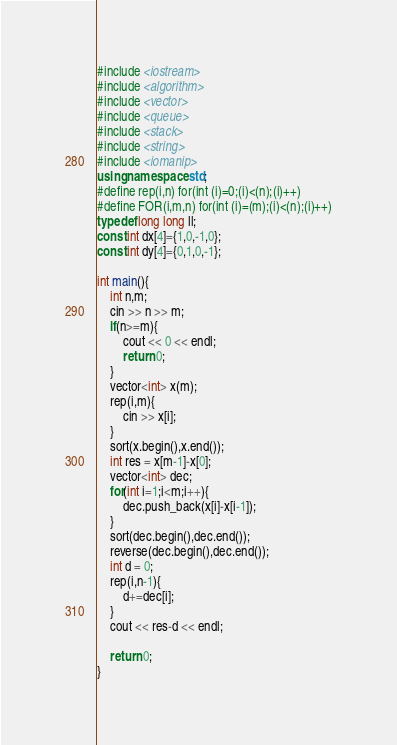Convert code to text. <code><loc_0><loc_0><loc_500><loc_500><_C++_>#include <iostream>
#include <algorithm>
#include <vector>
#include <queue>
#include <stack>
#include <string>
#include <iomanip>
using namespace std;
#define rep(i,n) for(int (i)=0;(i)<(n);(i)++)
#define FOR(i,m,n) for(int (i)=(m);(i)<(n);(i)++)
typedef long long ll;
const int dx[4]={1,0,-1,0};
const int dy[4]={0,1,0,-1};

int main(){
    int n,m;
    cin >> n >> m;
    if(n>=m){
        cout << 0 << endl;
        return 0;
    }
    vector<int> x(m);
    rep(i,m){
        cin >> x[i];
    }
    sort(x.begin(),x.end());
    int res = x[m-1]-x[0];
    vector<int> dec;
    for(int i=1;i<m;i++){
        dec.push_back(x[i]-x[i-1]);
    }
    sort(dec.begin(),dec.end());
    reverse(dec.begin(),dec.end());
    int d = 0;
    rep(i,n-1){
        d+=dec[i];
    }
    cout << res-d << endl;

    return 0;
}</code> 